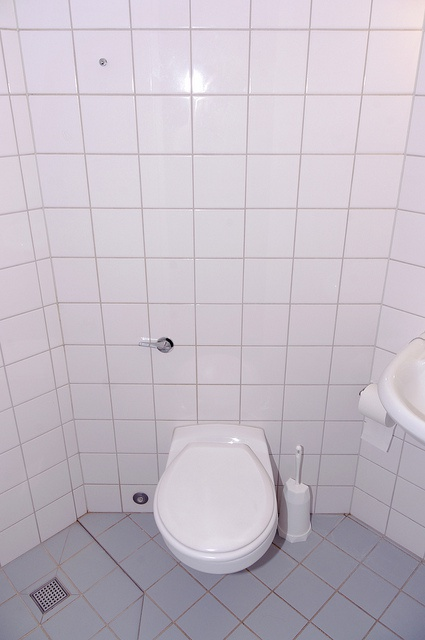Describe the objects in this image and their specific colors. I can see toilet in lavender, lightgray, and darkgray tones and sink in lavender, lightgray, and darkgray tones in this image. 